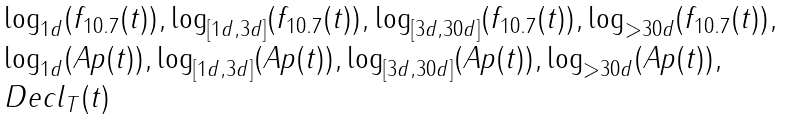<formula> <loc_0><loc_0><loc_500><loc_500>\begin{array} { l } \log _ { 1 d } ( f _ { 1 0 . 7 } ( t ) ) , \log _ { [ 1 d , 3 d ] } ( f _ { 1 0 . 7 } ( t ) ) , \log _ { [ 3 d , 3 0 d ] } ( f _ { 1 0 . 7 } ( t ) ) , \log _ { > 3 0 d } ( f _ { 1 0 . 7 } ( t ) ) , \\ \log _ { 1 d } ( A p ( t ) ) , \log _ { [ 1 d , 3 d ] } ( A p ( t ) ) , \log _ { [ 3 d , 3 0 d ] } ( A p ( t ) ) , \log _ { > 3 0 d } ( A p ( t ) ) , \\ D e c l _ { T } ( t ) \end{array}</formula> 